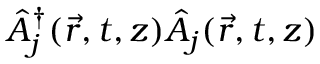<formula> <loc_0><loc_0><loc_500><loc_500>\hat { A } _ { j } ^ { \dagger } ( \vec { r } , t , z ) \hat { A } _ { j } ( \vec { r } , t , z )</formula> 